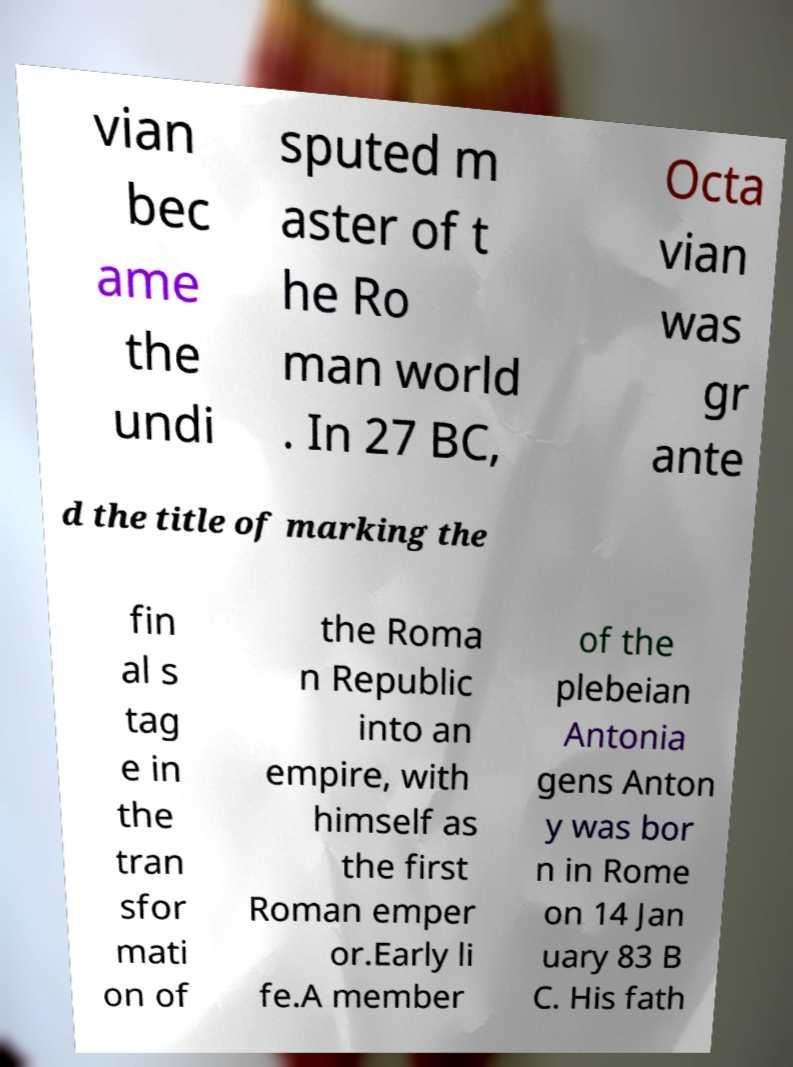What messages or text are displayed in this image? I need them in a readable, typed format. vian bec ame the undi sputed m aster of t he Ro man world . In 27 BC, Octa vian was gr ante d the title of marking the fin al s tag e in the tran sfor mati on of the Roma n Republic into an empire, with himself as the first Roman emper or.Early li fe.A member of the plebeian Antonia gens Anton y was bor n in Rome on 14 Jan uary 83 B C. His fath 